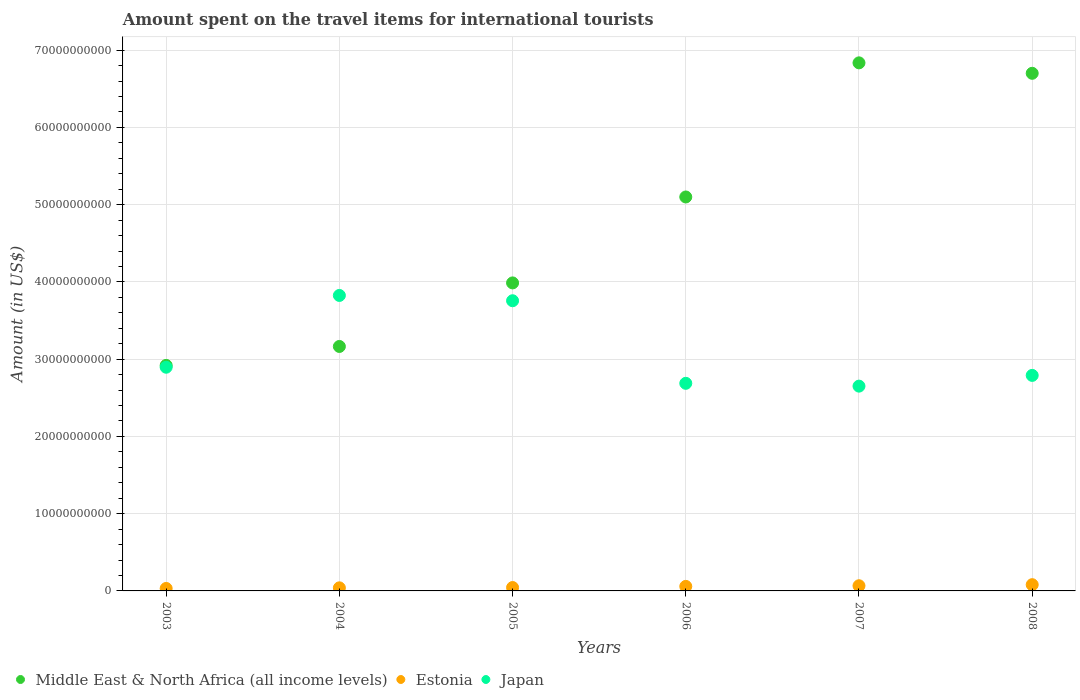Is the number of dotlines equal to the number of legend labels?
Keep it short and to the point. Yes. What is the amount spent on the travel items for international tourists in Estonia in 2005?
Your answer should be very brief. 4.39e+08. Across all years, what is the maximum amount spent on the travel items for international tourists in Estonia?
Provide a short and direct response. 8.09e+08. Across all years, what is the minimum amount spent on the travel items for international tourists in Middle East & North Africa (all income levels)?
Your answer should be very brief. 2.92e+1. In which year was the amount spent on the travel items for international tourists in Middle East & North Africa (all income levels) maximum?
Your answer should be compact. 2007. In which year was the amount spent on the travel items for international tourists in Japan minimum?
Provide a succinct answer. 2007. What is the total amount spent on the travel items for international tourists in Middle East & North Africa (all income levels) in the graph?
Offer a terse response. 2.87e+11. What is the difference between the amount spent on the travel items for international tourists in Estonia in 2003 and that in 2008?
Offer a very short reply. -4.90e+08. What is the difference between the amount spent on the travel items for international tourists in Middle East & North Africa (all income levels) in 2003 and the amount spent on the travel items for international tourists in Japan in 2008?
Keep it short and to the point. 1.29e+09. What is the average amount spent on the travel items for international tourists in Estonia per year?
Provide a succinct answer. 5.37e+08. In the year 2008, what is the difference between the amount spent on the travel items for international tourists in Middle East & North Africa (all income levels) and amount spent on the travel items for international tourists in Estonia?
Offer a very short reply. 6.62e+1. What is the ratio of the amount spent on the travel items for international tourists in Middle East & North Africa (all income levels) in 2007 to that in 2008?
Give a very brief answer. 1.02. Is the difference between the amount spent on the travel items for international tourists in Middle East & North Africa (all income levels) in 2004 and 2005 greater than the difference between the amount spent on the travel items for international tourists in Estonia in 2004 and 2005?
Give a very brief answer. No. What is the difference between the highest and the second highest amount spent on the travel items for international tourists in Japan?
Provide a succinct answer. 6.87e+08. What is the difference between the highest and the lowest amount spent on the travel items for international tourists in Estonia?
Keep it short and to the point. 4.90e+08. Is it the case that in every year, the sum of the amount spent on the travel items for international tourists in Middle East & North Africa (all income levels) and amount spent on the travel items for international tourists in Japan  is greater than the amount spent on the travel items for international tourists in Estonia?
Your response must be concise. Yes. Is the amount spent on the travel items for international tourists in Middle East & North Africa (all income levels) strictly greater than the amount spent on the travel items for international tourists in Estonia over the years?
Provide a succinct answer. Yes. What is the difference between two consecutive major ticks on the Y-axis?
Your answer should be very brief. 1.00e+1. Does the graph contain grids?
Offer a very short reply. Yes. Where does the legend appear in the graph?
Your response must be concise. Bottom left. How are the legend labels stacked?
Provide a short and direct response. Horizontal. What is the title of the graph?
Provide a short and direct response. Amount spent on the travel items for international tourists. Does "Cayman Islands" appear as one of the legend labels in the graph?
Your response must be concise. No. What is the label or title of the Y-axis?
Keep it short and to the point. Amount (in US$). What is the Amount (in US$) in Middle East & North Africa (all income levels) in 2003?
Make the answer very short. 2.92e+1. What is the Amount (in US$) of Estonia in 2003?
Your response must be concise. 3.19e+08. What is the Amount (in US$) in Japan in 2003?
Provide a short and direct response. 2.90e+1. What is the Amount (in US$) of Middle East & North Africa (all income levels) in 2004?
Make the answer very short. 3.16e+1. What is the Amount (in US$) of Estonia in 2004?
Keep it short and to the point. 3.99e+08. What is the Amount (in US$) of Japan in 2004?
Offer a terse response. 3.83e+1. What is the Amount (in US$) in Middle East & North Africa (all income levels) in 2005?
Offer a very short reply. 3.99e+1. What is the Amount (in US$) in Estonia in 2005?
Offer a terse response. 4.39e+08. What is the Amount (in US$) in Japan in 2005?
Ensure brevity in your answer.  3.76e+1. What is the Amount (in US$) of Middle East & North Africa (all income levels) in 2006?
Keep it short and to the point. 5.10e+1. What is the Amount (in US$) of Estonia in 2006?
Provide a succinct answer. 5.86e+08. What is the Amount (in US$) in Japan in 2006?
Keep it short and to the point. 2.69e+1. What is the Amount (in US$) of Middle East & North Africa (all income levels) in 2007?
Your response must be concise. 6.84e+1. What is the Amount (in US$) in Estonia in 2007?
Keep it short and to the point. 6.70e+08. What is the Amount (in US$) of Japan in 2007?
Provide a succinct answer. 2.65e+1. What is the Amount (in US$) in Middle East & North Africa (all income levels) in 2008?
Your answer should be very brief. 6.70e+1. What is the Amount (in US$) of Estonia in 2008?
Offer a very short reply. 8.09e+08. What is the Amount (in US$) of Japan in 2008?
Your answer should be compact. 2.79e+1. Across all years, what is the maximum Amount (in US$) in Middle East & North Africa (all income levels)?
Offer a very short reply. 6.84e+1. Across all years, what is the maximum Amount (in US$) in Estonia?
Ensure brevity in your answer.  8.09e+08. Across all years, what is the maximum Amount (in US$) of Japan?
Provide a succinct answer. 3.83e+1. Across all years, what is the minimum Amount (in US$) in Middle East & North Africa (all income levels)?
Give a very brief answer. 2.92e+1. Across all years, what is the minimum Amount (in US$) in Estonia?
Ensure brevity in your answer.  3.19e+08. Across all years, what is the minimum Amount (in US$) of Japan?
Offer a very short reply. 2.65e+1. What is the total Amount (in US$) of Middle East & North Africa (all income levels) in the graph?
Provide a short and direct response. 2.87e+11. What is the total Amount (in US$) of Estonia in the graph?
Ensure brevity in your answer.  3.22e+09. What is the total Amount (in US$) of Japan in the graph?
Provide a succinct answer. 1.86e+11. What is the difference between the Amount (in US$) of Middle East & North Africa (all income levels) in 2003 and that in 2004?
Ensure brevity in your answer.  -2.45e+09. What is the difference between the Amount (in US$) in Estonia in 2003 and that in 2004?
Offer a very short reply. -8.00e+07. What is the difference between the Amount (in US$) in Japan in 2003 and that in 2004?
Provide a succinct answer. -9.29e+09. What is the difference between the Amount (in US$) of Middle East & North Africa (all income levels) in 2003 and that in 2005?
Ensure brevity in your answer.  -1.07e+1. What is the difference between the Amount (in US$) in Estonia in 2003 and that in 2005?
Offer a terse response. -1.20e+08. What is the difference between the Amount (in US$) of Japan in 2003 and that in 2005?
Make the answer very short. -8.61e+09. What is the difference between the Amount (in US$) in Middle East & North Africa (all income levels) in 2003 and that in 2006?
Keep it short and to the point. -2.18e+1. What is the difference between the Amount (in US$) of Estonia in 2003 and that in 2006?
Give a very brief answer. -2.67e+08. What is the difference between the Amount (in US$) of Japan in 2003 and that in 2006?
Your response must be concise. 2.08e+09. What is the difference between the Amount (in US$) of Middle East & North Africa (all income levels) in 2003 and that in 2007?
Keep it short and to the point. -3.92e+1. What is the difference between the Amount (in US$) of Estonia in 2003 and that in 2007?
Offer a very short reply. -3.51e+08. What is the difference between the Amount (in US$) in Japan in 2003 and that in 2007?
Provide a short and direct response. 2.45e+09. What is the difference between the Amount (in US$) of Middle East & North Africa (all income levels) in 2003 and that in 2008?
Provide a short and direct response. -3.78e+1. What is the difference between the Amount (in US$) of Estonia in 2003 and that in 2008?
Offer a terse response. -4.90e+08. What is the difference between the Amount (in US$) of Japan in 2003 and that in 2008?
Your response must be concise. 1.06e+09. What is the difference between the Amount (in US$) of Middle East & North Africa (all income levels) in 2004 and that in 2005?
Make the answer very short. -8.23e+09. What is the difference between the Amount (in US$) in Estonia in 2004 and that in 2005?
Make the answer very short. -4.00e+07. What is the difference between the Amount (in US$) of Japan in 2004 and that in 2005?
Provide a short and direct response. 6.87e+08. What is the difference between the Amount (in US$) of Middle East & North Africa (all income levels) in 2004 and that in 2006?
Offer a terse response. -1.94e+1. What is the difference between the Amount (in US$) of Estonia in 2004 and that in 2006?
Offer a terse response. -1.87e+08. What is the difference between the Amount (in US$) of Japan in 2004 and that in 2006?
Your answer should be compact. 1.14e+1. What is the difference between the Amount (in US$) in Middle East & North Africa (all income levels) in 2004 and that in 2007?
Offer a very short reply. -3.67e+1. What is the difference between the Amount (in US$) in Estonia in 2004 and that in 2007?
Give a very brief answer. -2.71e+08. What is the difference between the Amount (in US$) in Japan in 2004 and that in 2007?
Offer a very short reply. 1.17e+1. What is the difference between the Amount (in US$) in Middle East & North Africa (all income levels) in 2004 and that in 2008?
Offer a terse response. -3.54e+1. What is the difference between the Amount (in US$) of Estonia in 2004 and that in 2008?
Offer a very short reply. -4.10e+08. What is the difference between the Amount (in US$) in Japan in 2004 and that in 2008?
Your answer should be very brief. 1.04e+1. What is the difference between the Amount (in US$) of Middle East & North Africa (all income levels) in 2005 and that in 2006?
Your answer should be compact. -1.11e+1. What is the difference between the Amount (in US$) in Estonia in 2005 and that in 2006?
Provide a succinct answer. -1.47e+08. What is the difference between the Amount (in US$) of Japan in 2005 and that in 2006?
Your answer should be very brief. 1.07e+1. What is the difference between the Amount (in US$) of Middle East & North Africa (all income levels) in 2005 and that in 2007?
Offer a very short reply. -2.85e+1. What is the difference between the Amount (in US$) in Estonia in 2005 and that in 2007?
Provide a short and direct response. -2.31e+08. What is the difference between the Amount (in US$) of Japan in 2005 and that in 2007?
Make the answer very short. 1.11e+1. What is the difference between the Amount (in US$) in Middle East & North Africa (all income levels) in 2005 and that in 2008?
Make the answer very short. -2.71e+1. What is the difference between the Amount (in US$) in Estonia in 2005 and that in 2008?
Offer a terse response. -3.70e+08. What is the difference between the Amount (in US$) of Japan in 2005 and that in 2008?
Provide a short and direct response. 9.66e+09. What is the difference between the Amount (in US$) of Middle East & North Africa (all income levels) in 2006 and that in 2007?
Provide a succinct answer. -1.74e+1. What is the difference between the Amount (in US$) of Estonia in 2006 and that in 2007?
Provide a short and direct response. -8.40e+07. What is the difference between the Amount (in US$) of Japan in 2006 and that in 2007?
Offer a terse response. 3.65e+08. What is the difference between the Amount (in US$) of Middle East & North Africa (all income levels) in 2006 and that in 2008?
Offer a terse response. -1.60e+1. What is the difference between the Amount (in US$) of Estonia in 2006 and that in 2008?
Your response must be concise. -2.23e+08. What is the difference between the Amount (in US$) of Japan in 2006 and that in 2008?
Ensure brevity in your answer.  -1.02e+09. What is the difference between the Amount (in US$) of Middle East & North Africa (all income levels) in 2007 and that in 2008?
Offer a very short reply. 1.35e+09. What is the difference between the Amount (in US$) of Estonia in 2007 and that in 2008?
Give a very brief answer. -1.39e+08. What is the difference between the Amount (in US$) of Japan in 2007 and that in 2008?
Offer a very short reply. -1.39e+09. What is the difference between the Amount (in US$) in Middle East & North Africa (all income levels) in 2003 and the Amount (in US$) in Estonia in 2004?
Offer a terse response. 2.88e+1. What is the difference between the Amount (in US$) of Middle East & North Africa (all income levels) in 2003 and the Amount (in US$) of Japan in 2004?
Keep it short and to the point. -9.06e+09. What is the difference between the Amount (in US$) in Estonia in 2003 and the Amount (in US$) in Japan in 2004?
Keep it short and to the point. -3.79e+1. What is the difference between the Amount (in US$) in Middle East & North Africa (all income levels) in 2003 and the Amount (in US$) in Estonia in 2005?
Your answer should be compact. 2.88e+1. What is the difference between the Amount (in US$) in Middle East & North Africa (all income levels) in 2003 and the Amount (in US$) in Japan in 2005?
Keep it short and to the point. -8.37e+09. What is the difference between the Amount (in US$) in Estonia in 2003 and the Amount (in US$) in Japan in 2005?
Keep it short and to the point. -3.72e+1. What is the difference between the Amount (in US$) of Middle East & North Africa (all income levels) in 2003 and the Amount (in US$) of Estonia in 2006?
Your answer should be compact. 2.86e+1. What is the difference between the Amount (in US$) in Middle East & North Africa (all income levels) in 2003 and the Amount (in US$) in Japan in 2006?
Provide a succinct answer. 2.32e+09. What is the difference between the Amount (in US$) in Estonia in 2003 and the Amount (in US$) in Japan in 2006?
Your response must be concise. -2.66e+1. What is the difference between the Amount (in US$) in Middle East & North Africa (all income levels) in 2003 and the Amount (in US$) in Estonia in 2007?
Keep it short and to the point. 2.85e+1. What is the difference between the Amount (in US$) of Middle East & North Africa (all income levels) in 2003 and the Amount (in US$) of Japan in 2007?
Keep it short and to the point. 2.68e+09. What is the difference between the Amount (in US$) of Estonia in 2003 and the Amount (in US$) of Japan in 2007?
Provide a short and direct response. -2.62e+1. What is the difference between the Amount (in US$) in Middle East & North Africa (all income levels) in 2003 and the Amount (in US$) in Estonia in 2008?
Offer a very short reply. 2.84e+1. What is the difference between the Amount (in US$) in Middle East & North Africa (all income levels) in 2003 and the Amount (in US$) in Japan in 2008?
Make the answer very short. 1.29e+09. What is the difference between the Amount (in US$) of Estonia in 2003 and the Amount (in US$) of Japan in 2008?
Offer a very short reply. -2.76e+1. What is the difference between the Amount (in US$) of Middle East & North Africa (all income levels) in 2004 and the Amount (in US$) of Estonia in 2005?
Your answer should be very brief. 3.12e+1. What is the difference between the Amount (in US$) of Middle East & North Africa (all income levels) in 2004 and the Amount (in US$) of Japan in 2005?
Provide a succinct answer. -5.92e+09. What is the difference between the Amount (in US$) of Estonia in 2004 and the Amount (in US$) of Japan in 2005?
Your answer should be very brief. -3.72e+1. What is the difference between the Amount (in US$) of Middle East & North Africa (all income levels) in 2004 and the Amount (in US$) of Estonia in 2006?
Offer a terse response. 3.11e+1. What is the difference between the Amount (in US$) of Middle East & North Africa (all income levels) in 2004 and the Amount (in US$) of Japan in 2006?
Offer a very short reply. 4.77e+09. What is the difference between the Amount (in US$) of Estonia in 2004 and the Amount (in US$) of Japan in 2006?
Ensure brevity in your answer.  -2.65e+1. What is the difference between the Amount (in US$) in Middle East & North Africa (all income levels) in 2004 and the Amount (in US$) in Estonia in 2007?
Make the answer very short. 3.10e+1. What is the difference between the Amount (in US$) in Middle East & North Africa (all income levels) in 2004 and the Amount (in US$) in Japan in 2007?
Give a very brief answer. 5.14e+09. What is the difference between the Amount (in US$) of Estonia in 2004 and the Amount (in US$) of Japan in 2007?
Offer a very short reply. -2.61e+1. What is the difference between the Amount (in US$) of Middle East & North Africa (all income levels) in 2004 and the Amount (in US$) of Estonia in 2008?
Offer a very short reply. 3.08e+1. What is the difference between the Amount (in US$) in Middle East & North Africa (all income levels) in 2004 and the Amount (in US$) in Japan in 2008?
Offer a very short reply. 3.75e+09. What is the difference between the Amount (in US$) of Estonia in 2004 and the Amount (in US$) of Japan in 2008?
Provide a succinct answer. -2.75e+1. What is the difference between the Amount (in US$) in Middle East & North Africa (all income levels) in 2005 and the Amount (in US$) in Estonia in 2006?
Offer a very short reply. 3.93e+1. What is the difference between the Amount (in US$) in Middle East & North Africa (all income levels) in 2005 and the Amount (in US$) in Japan in 2006?
Provide a short and direct response. 1.30e+1. What is the difference between the Amount (in US$) of Estonia in 2005 and the Amount (in US$) of Japan in 2006?
Provide a short and direct response. -2.64e+1. What is the difference between the Amount (in US$) in Middle East & North Africa (all income levels) in 2005 and the Amount (in US$) in Estonia in 2007?
Make the answer very short. 3.92e+1. What is the difference between the Amount (in US$) in Middle East & North Africa (all income levels) in 2005 and the Amount (in US$) in Japan in 2007?
Make the answer very short. 1.34e+1. What is the difference between the Amount (in US$) in Estonia in 2005 and the Amount (in US$) in Japan in 2007?
Provide a succinct answer. -2.61e+1. What is the difference between the Amount (in US$) of Middle East & North Africa (all income levels) in 2005 and the Amount (in US$) of Estonia in 2008?
Provide a succinct answer. 3.91e+1. What is the difference between the Amount (in US$) in Middle East & North Africa (all income levels) in 2005 and the Amount (in US$) in Japan in 2008?
Offer a very short reply. 1.20e+1. What is the difference between the Amount (in US$) of Estonia in 2005 and the Amount (in US$) of Japan in 2008?
Give a very brief answer. -2.75e+1. What is the difference between the Amount (in US$) of Middle East & North Africa (all income levels) in 2006 and the Amount (in US$) of Estonia in 2007?
Your response must be concise. 5.03e+1. What is the difference between the Amount (in US$) in Middle East & North Africa (all income levels) in 2006 and the Amount (in US$) in Japan in 2007?
Your response must be concise. 2.45e+1. What is the difference between the Amount (in US$) of Estonia in 2006 and the Amount (in US$) of Japan in 2007?
Your answer should be compact. -2.59e+1. What is the difference between the Amount (in US$) of Middle East & North Africa (all income levels) in 2006 and the Amount (in US$) of Estonia in 2008?
Your answer should be very brief. 5.02e+1. What is the difference between the Amount (in US$) in Middle East & North Africa (all income levels) in 2006 and the Amount (in US$) in Japan in 2008?
Ensure brevity in your answer.  2.31e+1. What is the difference between the Amount (in US$) of Estonia in 2006 and the Amount (in US$) of Japan in 2008?
Make the answer very short. -2.73e+1. What is the difference between the Amount (in US$) of Middle East & North Africa (all income levels) in 2007 and the Amount (in US$) of Estonia in 2008?
Provide a short and direct response. 6.76e+1. What is the difference between the Amount (in US$) of Middle East & North Africa (all income levels) in 2007 and the Amount (in US$) of Japan in 2008?
Give a very brief answer. 4.05e+1. What is the difference between the Amount (in US$) of Estonia in 2007 and the Amount (in US$) of Japan in 2008?
Offer a terse response. -2.72e+1. What is the average Amount (in US$) in Middle East & North Africa (all income levels) per year?
Provide a succinct answer. 4.78e+1. What is the average Amount (in US$) of Estonia per year?
Ensure brevity in your answer.  5.37e+08. What is the average Amount (in US$) in Japan per year?
Keep it short and to the point. 3.10e+1. In the year 2003, what is the difference between the Amount (in US$) of Middle East & North Africa (all income levels) and Amount (in US$) of Estonia?
Keep it short and to the point. 2.89e+1. In the year 2003, what is the difference between the Amount (in US$) of Middle East & North Africa (all income levels) and Amount (in US$) of Japan?
Make the answer very short. 2.35e+08. In the year 2003, what is the difference between the Amount (in US$) in Estonia and Amount (in US$) in Japan?
Keep it short and to the point. -2.86e+1. In the year 2004, what is the difference between the Amount (in US$) in Middle East & North Africa (all income levels) and Amount (in US$) in Estonia?
Offer a very short reply. 3.12e+1. In the year 2004, what is the difference between the Amount (in US$) of Middle East & North Africa (all income levels) and Amount (in US$) of Japan?
Offer a terse response. -6.60e+09. In the year 2004, what is the difference between the Amount (in US$) of Estonia and Amount (in US$) of Japan?
Offer a very short reply. -3.79e+1. In the year 2005, what is the difference between the Amount (in US$) of Middle East & North Africa (all income levels) and Amount (in US$) of Estonia?
Your response must be concise. 3.94e+1. In the year 2005, what is the difference between the Amount (in US$) of Middle East & North Africa (all income levels) and Amount (in US$) of Japan?
Provide a short and direct response. 2.31e+09. In the year 2005, what is the difference between the Amount (in US$) in Estonia and Amount (in US$) in Japan?
Your response must be concise. -3.71e+1. In the year 2006, what is the difference between the Amount (in US$) of Middle East & North Africa (all income levels) and Amount (in US$) of Estonia?
Provide a succinct answer. 5.04e+1. In the year 2006, what is the difference between the Amount (in US$) in Middle East & North Africa (all income levels) and Amount (in US$) in Japan?
Provide a succinct answer. 2.41e+1. In the year 2006, what is the difference between the Amount (in US$) of Estonia and Amount (in US$) of Japan?
Your response must be concise. -2.63e+1. In the year 2007, what is the difference between the Amount (in US$) of Middle East & North Africa (all income levels) and Amount (in US$) of Estonia?
Keep it short and to the point. 6.77e+1. In the year 2007, what is the difference between the Amount (in US$) in Middle East & North Africa (all income levels) and Amount (in US$) in Japan?
Ensure brevity in your answer.  4.19e+1. In the year 2007, what is the difference between the Amount (in US$) in Estonia and Amount (in US$) in Japan?
Provide a short and direct response. -2.58e+1. In the year 2008, what is the difference between the Amount (in US$) of Middle East & North Africa (all income levels) and Amount (in US$) of Estonia?
Provide a short and direct response. 6.62e+1. In the year 2008, what is the difference between the Amount (in US$) of Middle East & North Africa (all income levels) and Amount (in US$) of Japan?
Offer a terse response. 3.91e+1. In the year 2008, what is the difference between the Amount (in US$) in Estonia and Amount (in US$) in Japan?
Your answer should be very brief. -2.71e+1. What is the ratio of the Amount (in US$) in Middle East & North Africa (all income levels) in 2003 to that in 2004?
Provide a short and direct response. 0.92. What is the ratio of the Amount (in US$) in Estonia in 2003 to that in 2004?
Your answer should be very brief. 0.8. What is the ratio of the Amount (in US$) of Japan in 2003 to that in 2004?
Offer a terse response. 0.76. What is the ratio of the Amount (in US$) of Middle East & North Africa (all income levels) in 2003 to that in 2005?
Provide a succinct answer. 0.73. What is the ratio of the Amount (in US$) in Estonia in 2003 to that in 2005?
Your answer should be compact. 0.73. What is the ratio of the Amount (in US$) of Japan in 2003 to that in 2005?
Provide a short and direct response. 0.77. What is the ratio of the Amount (in US$) in Middle East & North Africa (all income levels) in 2003 to that in 2006?
Provide a succinct answer. 0.57. What is the ratio of the Amount (in US$) of Estonia in 2003 to that in 2006?
Offer a terse response. 0.54. What is the ratio of the Amount (in US$) of Japan in 2003 to that in 2006?
Give a very brief answer. 1.08. What is the ratio of the Amount (in US$) in Middle East & North Africa (all income levels) in 2003 to that in 2007?
Provide a succinct answer. 0.43. What is the ratio of the Amount (in US$) in Estonia in 2003 to that in 2007?
Provide a succinct answer. 0.48. What is the ratio of the Amount (in US$) in Japan in 2003 to that in 2007?
Your answer should be compact. 1.09. What is the ratio of the Amount (in US$) in Middle East & North Africa (all income levels) in 2003 to that in 2008?
Offer a very short reply. 0.44. What is the ratio of the Amount (in US$) of Estonia in 2003 to that in 2008?
Keep it short and to the point. 0.39. What is the ratio of the Amount (in US$) of Japan in 2003 to that in 2008?
Your answer should be very brief. 1.04. What is the ratio of the Amount (in US$) in Middle East & North Africa (all income levels) in 2004 to that in 2005?
Keep it short and to the point. 0.79. What is the ratio of the Amount (in US$) of Estonia in 2004 to that in 2005?
Provide a short and direct response. 0.91. What is the ratio of the Amount (in US$) in Japan in 2004 to that in 2005?
Your answer should be very brief. 1.02. What is the ratio of the Amount (in US$) in Middle East & North Africa (all income levels) in 2004 to that in 2006?
Make the answer very short. 0.62. What is the ratio of the Amount (in US$) in Estonia in 2004 to that in 2006?
Offer a very short reply. 0.68. What is the ratio of the Amount (in US$) in Japan in 2004 to that in 2006?
Provide a short and direct response. 1.42. What is the ratio of the Amount (in US$) in Middle East & North Africa (all income levels) in 2004 to that in 2007?
Offer a terse response. 0.46. What is the ratio of the Amount (in US$) in Estonia in 2004 to that in 2007?
Provide a succinct answer. 0.6. What is the ratio of the Amount (in US$) of Japan in 2004 to that in 2007?
Your answer should be very brief. 1.44. What is the ratio of the Amount (in US$) in Middle East & North Africa (all income levels) in 2004 to that in 2008?
Offer a very short reply. 0.47. What is the ratio of the Amount (in US$) of Estonia in 2004 to that in 2008?
Give a very brief answer. 0.49. What is the ratio of the Amount (in US$) in Japan in 2004 to that in 2008?
Give a very brief answer. 1.37. What is the ratio of the Amount (in US$) of Middle East & North Africa (all income levels) in 2005 to that in 2006?
Provide a succinct answer. 0.78. What is the ratio of the Amount (in US$) of Estonia in 2005 to that in 2006?
Your answer should be compact. 0.75. What is the ratio of the Amount (in US$) of Japan in 2005 to that in 2006?
Offer a very short reply. 1.4. What is the ratio of the Amount (in US$) in Middle East & North Africa (all income levels) in 2005 to that in 2007?
Your answer should be very brief. 0.58. What is the ratio of the Amount (in US$) in Estonia in 2005 to that in 2007?
Your response must be concise. 0.66. What is the ratio of the Amount (in US$) of Japan in 2005 to that in 2007?
Give a very brief answer. 1.42. What is the ratio of the Amount (in US$) in Middle East & North Africa (all income levels) in 2005 to that in 2008?
Provide a short and direct response. 0.6. What is the ratio of the Amount (in US$) of Estonia in 2005 to that in 2008?
Provide a short and direct response. 0.54. What is the ratio of the Amount (in US$) of Japan in 2005 to that in 2008?
Provide a short and direct response. 1.35. What is the ratio of the Amount (in US$) of Middle East & North Africa (all income levels) in 2006 to that in 2007?
Your answer should be compact. 0.75. What is the ratio of the Amount (in US$) of Estonia in 2006 to that in 2007?
Give a very brief answer. 0.87. What is the ratio of the Amount (in US$) of Japan in 2006 to that in 2007?
Offer a very short reply. 1.01. What is the ratio of the Amount (in US$) of Middle East & North Africa (all income levels) in 2006 to that in 2008?
Provide a succinct answer. 0.76. What is the ratio of the Amount (in US$) in Estonia in 2006 to that in 2008?
Your answer should be very brief. 0.72. What is the ratio of the Amount (in US$) of Japan in 2006 to that in 2008?
Offer a very short reply. 0.96. What is the ratio of the Amount (in US$) of Middle East & North Africa (all income levels) in 2007 to that in 2008?
Ensure brevity in your answer.  1.02. What is the ratio of the Amount (in US$) in Estonia in 2007 to that in 2008?
Your answer should be very brief. 0.83. What is the ratio of the Amount (in US$) in Japan in 2007 to that in 2008?
Make the answer very short. 0.95. What is the difference between the highest and the second highest Amount (in US$) in Middle East & North Africa (all income levels)?
Offer a very short reply. 1.35e+09. What is the difference between the highest and the second highest Amount (in US$) of Estonia?
Your response must be concise. 1.39e+08. What is the difference between the highest and the second highest Amount (in US$) in Japan?
Provide a short and direct response. 6.87e+08. What is the difference between the highest and the lowest Amount (in US$) of Middle East & North Africa (all income levels)?
Keep it short and to the point. 3.92e+1. What is the difference between the highest and the lowest Amount (in US$) of Estonia?
Your answer should be very brief. 4.90e+08. What is the difference between the highest and the lowest Amount (in US$) of Japan?
Offer a terse response. 1.17e+1. 